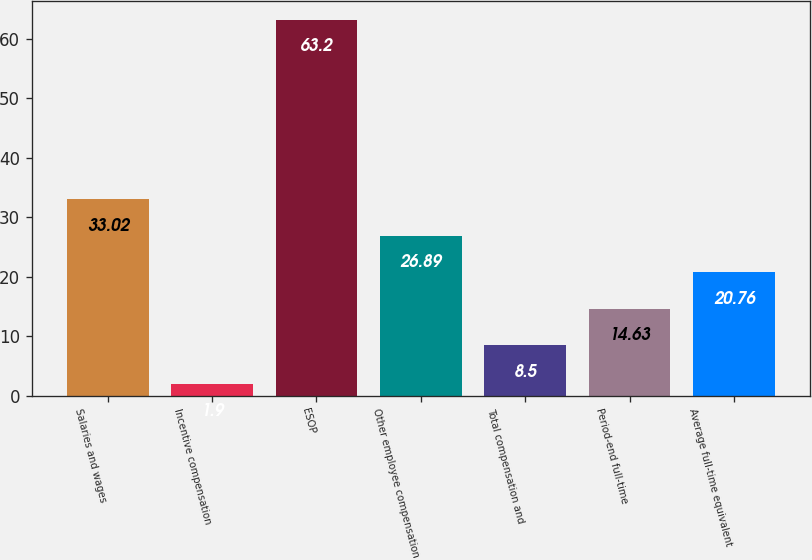<chart> <loc_0><loc_0><loc_500><loc_500><bar_chart><fcel>Salaries and wages<fcel>Incentive compensation<fcel>ESOP<fcel>Other employee compensation<fcel>Total compensation and<fcel>Period-end full-time<fcel>Average full-time equivalent<nl><fcel>33.02<fcel>1.9<fcel>63.2<fcel>26.89<fcel>8.5<fcel>14.63<fcel>20.76<nl></chart> 